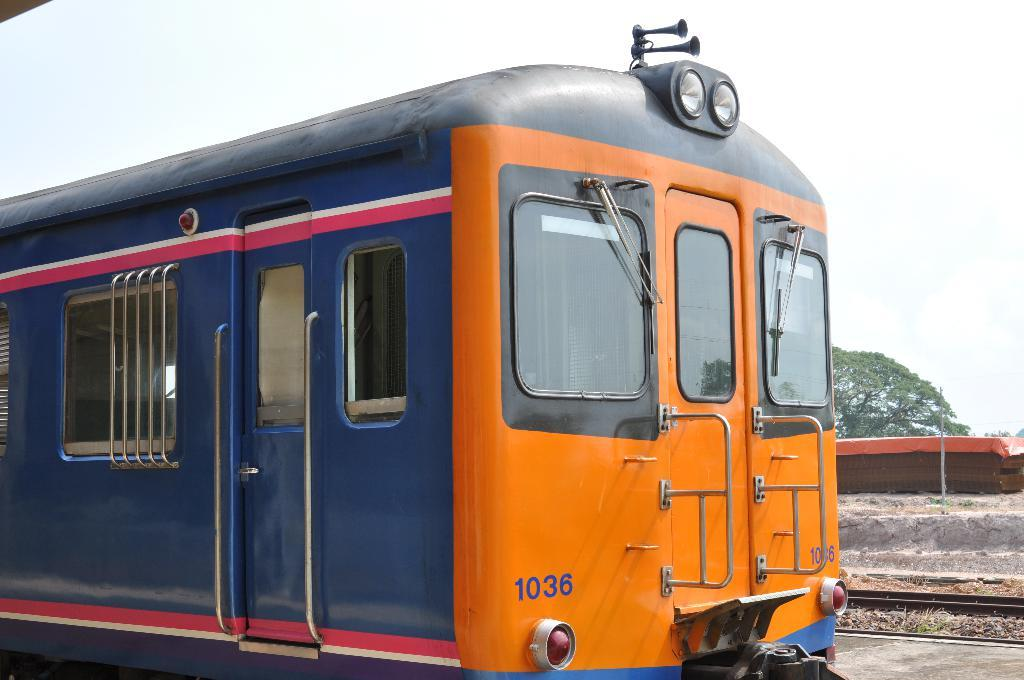What is the main subject of the image? There is a train in the image. What is behind the train in the image? There are railway tracks behind the train. Can you identify any natural elements in the image? Yes, there is a tree visible in the image. Where is the throne located in the image? There is no throne present in the image. What type of bell can be heard ringing in the image? There is no bell present in the image, and therefore no sound can be heard. 